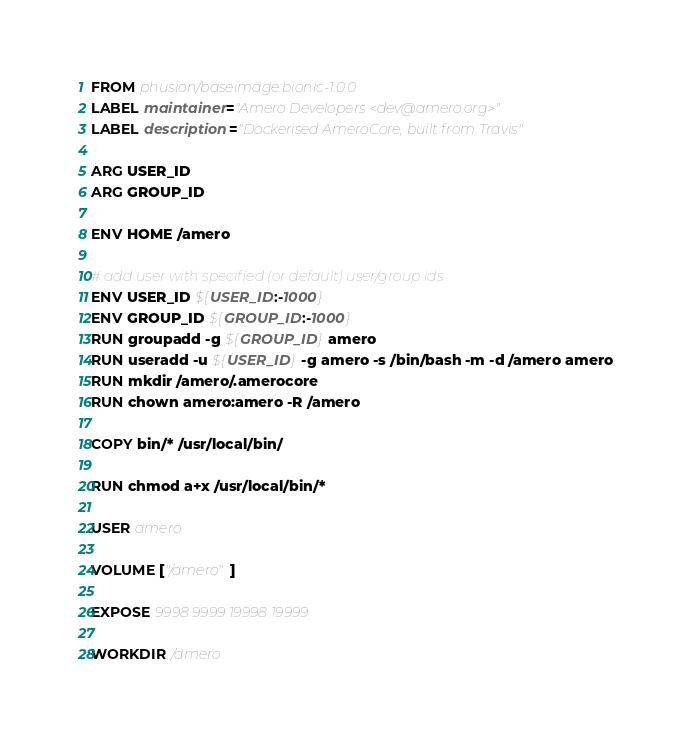<code> <loc_0><loc_0><loc_500><loc_500><_Dockerfile_>FROM phusion/baseimage:bionic-1.0.0
LABEL maintainer="Amero Developers <dev@amero.org>"
LABEL description="Dockerised AmeroCore, built from Travis"

ARG USER_ID
ARG GROUP_ID

ENV HOME /amero

# add user with specified (or default) user/group ids
ENV USER_ID ${USER_ID:-1000}
ENV GROUP_ID ${GROUP_ID:-1000}
RUN groupadd -g ${GROUP_ID} amero
RUN useradd -u ${USER_ID} -g amero -s /bin/bash -m -d /amero amero
RUN mkdir /amero/.amerocore
RUN chown amero:amero -R /amero

COPY bin/* /usr/local/bin/

RUN chmod a+x /usr/local/bin/*

USER amero

VOLUME ["/amero"]

EXPOSE 9998 9999 19998 19999

WORKDIR /amero
</code> 